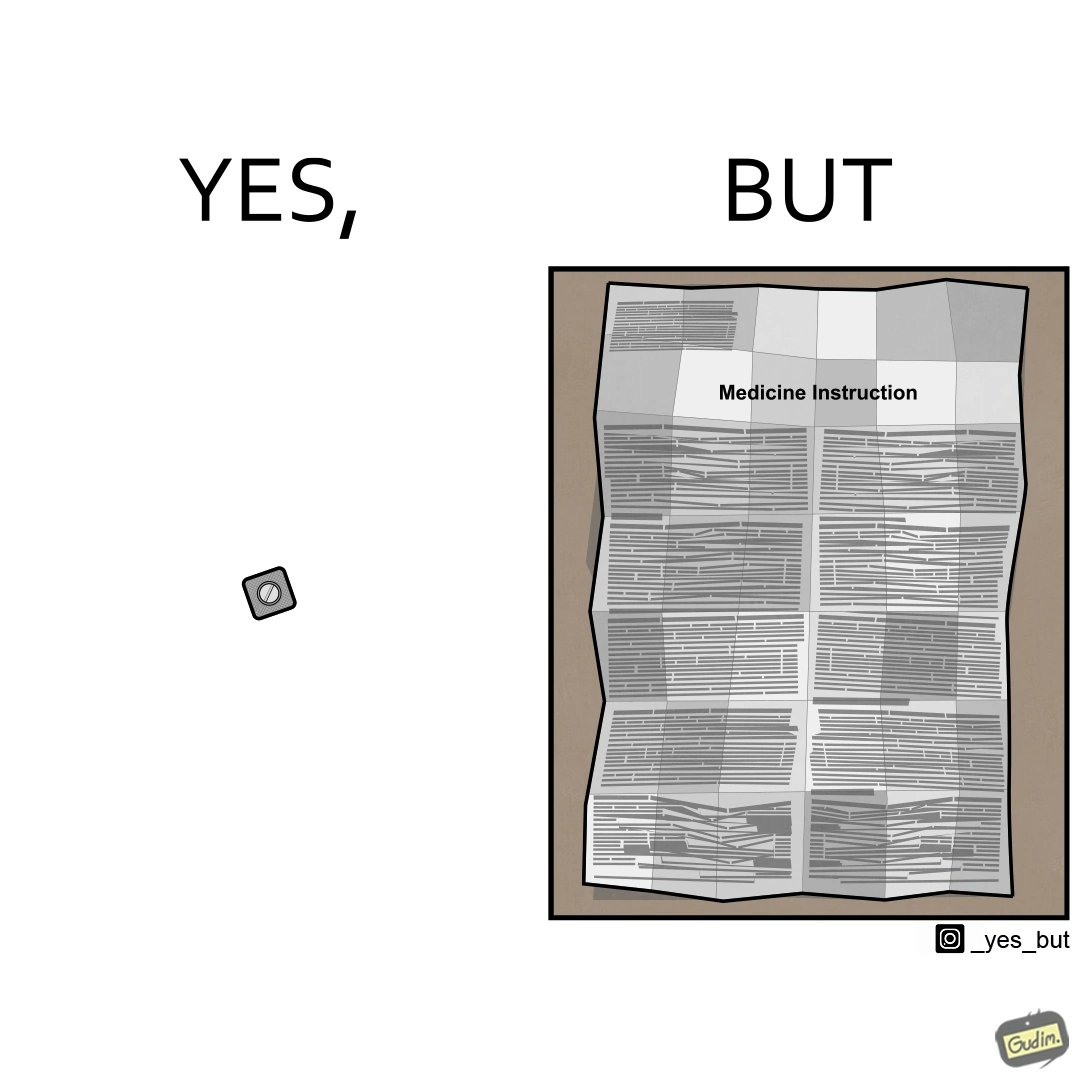Describe what you see in the left and right parts of this image. In the left part of the image: a small tablet of a medicine In the right part of the image: a leaflet describing the instructions for a medicine 